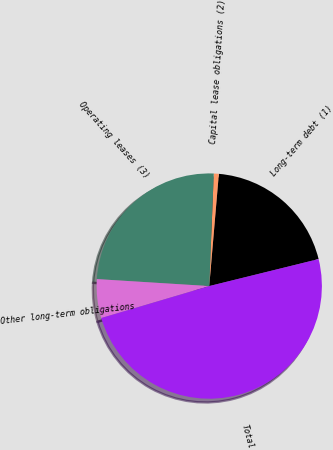Convert chart. <chart><loc_0><loc_0><loc_500><loc_500><pie_chart><fcel>Long-term debt (1)<fcel>Capital lease obligations (2)<fcel>Operating leases (3)<fcel>Other long-term obligations<fcel>Total<nl><fcel>19.79%<fcel>0.72%<fcel>24.65%<fcel>5.57%<fcel>49.27%<nl></chart> 